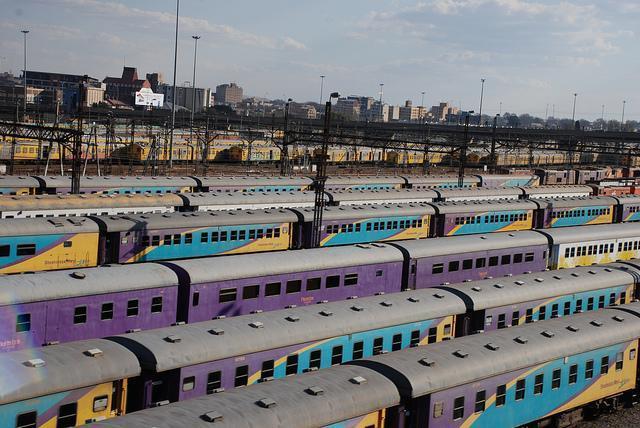How many trains are in the photo?
Give a very brief answer. 8. 